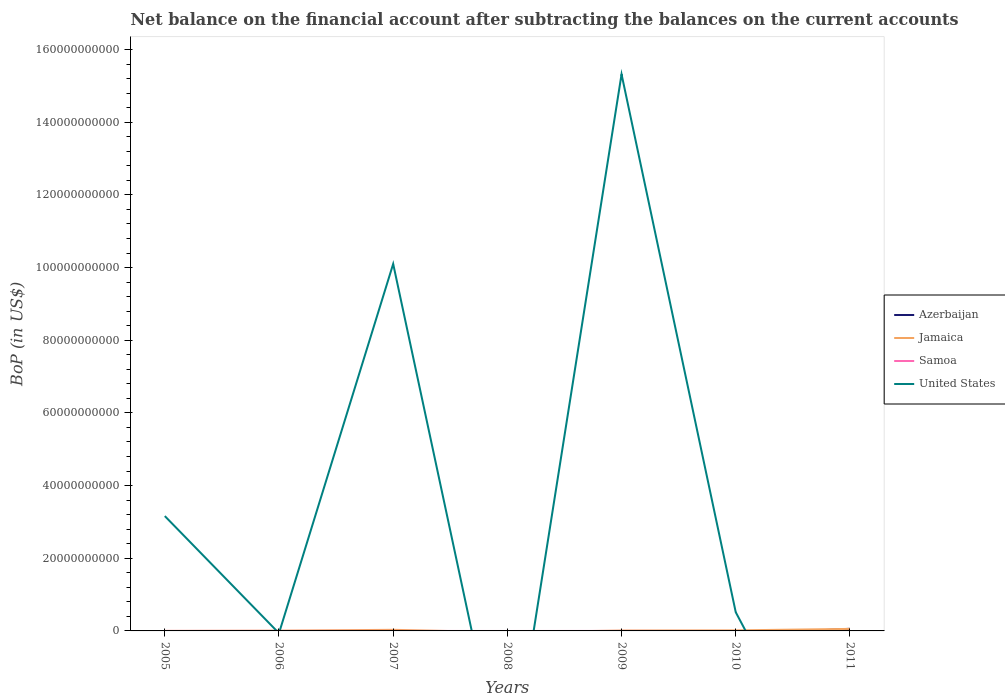How many different coloured lines are there?
Your answer should be compact. 4. Is the number of lines equal to the number of legend labels?
Ensure brevity in your answer.  No. What is the total Balance of Payments in Jamaica in the graph?
Your response must be concise. -7.87e+07. What is the difference between the highest and the second highest Balance of Payments in United States?
Your answer should be very brief. 1.53e+11. What is the difference between the highest and the lowest Balance of Payments in Azerbaijan?
Your response must be concise. 1. Is the Balance of Payments in Azerbaijan strictly greater than the Balance of Payments in Samoa over the years?
Ensure brevity in your answer.  No. How many lines are there?
Your response must be concise. 4. How many years are there in the graph?
Give a very brief answer. 7. Are the values on the major ticks of Y-axis written in scientific E-notation?
Offer a very short reply. No. Does the graph contain grids?
Make the answer very short. No. What is the title of the graph?
Make the answer very short. Net balance on the financial account after subtracting the balances on the current accounts. Does "Maldives" appear as one of the legend labels in the graph?
Give a very brief answer. No. What is the label or title of the Y-axis?
Give a very brief answer. BoP (in US$). What is the BoP (in US$) in Samoa in 2005?
Offer a terse response. 0. What is the BoP (in US$) in United States in 2005?
Ensure brevity in your answer.  3.16e+1. What is the BoP (in US$) of Jamaica in 2006?
Offer a terse response. 7.07e+07. What is the BoP (in US$) of Samoa in 2006?
Ensure brevity in your answer.  6.12e+06. What is the BoP (in US$) in United States in 2006?
Your response must be concise. 0. What is the BoP (in US$) of Azerbaijan in 2007?
Give a very brief answer. 0. What is the BoP (in US$) of Jamaica in 2007?
Keep it short and to the point. 3.03e+08. What is the BoP (in US$) in Samoa in 2007?
Make the answer very short. 0. What is the BoP (in US$) in United States in 2007?
Give a very brief answer. 1.01e+11. What is the BoP (in US$) in Azerbaijan in 2008?
Your response must be concise. 0. What is the BoP (in US$) of Jamaica in 2008?
Your response must be concise. 0. What is the BoP (in US$) in Samoa in 2008?
Keep it short and to the point. 0. What is the BoP (in US$) in Jamaica in 2009?
Make the answer very short. 1.03e+08. What is the BoP (in US$) of Samoa in 2009?
Your answer should be very brief. 2.61e+05. What is the BoP (in US$) of United States in 2009?
Make the answer very short. 1.53e+11. What is the BoP (in US$) of Azerbaijan in 2010?
Your answer should be very brief. 0. What is the BoP (in US$) of Jamaica in 2010?
Keep it short and to the point. 1.49e+08. What is the BoP (in US$) of United States in 2010?
Your answer should be compact. 5.15e+09. What is the BoP (in US$) of Azerbaijan in 2011?
Your answer should be compact. 5.87e+08. What is the BoP (in US$) of Jamaica in 2011?
Your answer should be very brief. 5.57e+08. What is the BoP (in US$) of United States in 2011?
Your answer should be compact. 0. Across all years, what is the maximum BoP (in US$) in Azerbaijan?
Make the answer very short. 5.87e+08. Across all years, what is the maximum BoP (in US$) of Jamaica?
Keep it short and to the point. 5.57e+08. Across all years, what is the maximum BoP (in US$) of Samoa?
Offer a terse response. 6.12e+06. Across all years, what is the maximum BoP (in US$) in United States?
Keep it short and to the point. 1.53e+11. Across all years, what is the minimum BoP (in US$) in Jamaica?
Your response must be concise. 0. What is the total BoP (in US$) of Azerbaijan in the graph?
Provide a succinct answer. 5.87e+08. What is the total BoP (in US$) in Jamaica in the graph?
Your answer should be compact. 1.18e+09. What is the total BoP (in US$) of Samoa in the graph?
Provide a short and direct response. 6.38e+06. What is the total BoP (in US$) in United States in the graph?
Provide a succinct answer. 2.91e+11. What is the difference between the BoP (in US$) of United States in 2005 and that in 2007?
Your answer should be compact. -6.94e+1. What is the difference between the BoP (in US$) in United States in 2005 and that in 2009?
Make the answer very short. -1.22e+11. What is the difference between the BoP (in US$) of United States in 2005 and that in 2010?
Ensure brevity in your answer.  2.65e+1. What is the difference between the BoP (in US$) in Jamaica in 2006 and that in 2007?
Provide a short and direct response. -2.33e+08. What is the difference between the BoP (in US$) in Jamaica in 2006 and that in 2009?
Provide a succinct answer. -3.23e+07. What is the difference between the BoP (in US$) of Samoa in 2006 and that in 2009?
Ensure brevity in your answer.  5.86e+06. What is the difference between the BoP (in US$) in Jamaica in 2006 and that in 2010?
Provide a succinct answer. -7.87e+07. What is the difference between the BoP (in US$) in Jamaica in 2006 and that in 2011?
Offer a terse response. -4.87e+08. What is the difference between the BoP (in US$) in Jamaica in 2007 and that in 2009?
Make the answer very short. 2.00e+08. What is the difference between the BoP (in US$) of United States in 2007 and that in 2009?
Provide a succinct answer. -5.22e+1. What is the difference between the BoP (in US$) in Jamaica in 2007 and that in 2010?
Offer a terse response. 1.54e+08. What is the difference between the BoP (in US$) of United States in 2007 and that in 2010?
Provide a succinct answer. 9.59e+1. What is the difference between the BoP (in US$) in Jamaica in 2007 and that in 2011?
Make the answer very short. -2.54e+08. What is the difference between the BoP (in US$) in Jamaica in 2009 and that in 2010?
Provide a short and direct response. -4.64e+07. What is the difference between the BoP (in US$) of United States in 2009 and that in 2010?
Give a very brief answer. 1.48e+11. What is the difference between the BoP (in US$) in Jamaica in 2009 and that in 2011?
Provide a succinct answer. -4.54e+08. What is the difference between the BoP (in US$) in Jamaica in 2010 and that in 2011?
Your answer should be very brief. -4.08e+08. What is the difference between the BoP (in US$) of Jamaica in 2006 and the BoP (in US$) of United States in 2007?
Offer a terse response. -1.01e+11. What is the difference between the BoP (in US$) in Samoa in 2006 and the BoP (in US$) in United States in 2007?
Your answer should be very brief. -1.01e+11. What is the difference between the BoP (in US$) of Jamaica in 2006 and the BoP (in US$) of Samoa in 2009?
Provide a short and direct response. 7.05e+07. What is the difference between the BoP (in US$) in Jamaica in 2006 and the BoP (in US$) in United States in 2009?
Keep it short and to the point. -1.53e+11. What is the difference between the BoP (in US$) of Samoa in 2006 and the BoP (in US$) of United States in 2009?
Provide a short and direct response. -1.53e+11. What is the difference between the BoP (in US$) of Jamaica in 2006 and the BoP (in US$) of United States in 2010?
Keep it short and to the point. -5.08e+09. What is the difference between the BoP (in US$) in Samoa in 2006 and the BoP (in US$) in United States in 2010?
Provide a succinct answer. -5.14e+09. What is the difference between the BoP (in US$) in Jamaica in 2007 and the BoP (in US$) in Samoa in 2009?
Make the answer very short. 3.03e+08. What is the difference between the BoP (in US$) in Jamaica in 2007 and the BoP (in US$) in United States in 2009?
Keep it short and to the point. -1.53e+11. What is the difference between the BoP (in US$) of Jamaica in 2007 and the BoP (in US$) of United States in 2010?
Your answer should be very brief. -4.84e+09. What is the difference between the BoP (in US$) of Jamaica in 2009 and the BoP (in US$) of United States in 2010?
Provide a short and direct response. -5.04e+09. What is the difference between the BoP (in US$) of Samoa in 2009 and the BoP (in US$) of United States in 2010?
Give a very brief answer. -5.15e+09. What is the average BoP (in US$) of Azerbaijan per year?
Your answer should be very brief. 8.38e+07. What is the average BoP (in US$) of Jamaica per year?
Provide a short and direct response. 1.69e+08. What is the average BoP (in US$) of Samoa per year?
Your response must be concise. 9.11e+05. What is the average BoP (in US$) of United States per year?
Provide a short and direct response. 4.16e+1. In the year 2006, what is the difference between the BoP (in US$) in Jamaica and BoP (in US$) in Samoa?
Keep it short and to the point. 6.46e+07. In the year 2007, what is the difference between the BoP (in US$) of Jamaica and BoP (in US$) of United States?
Your answer should be very brief. -1.01e+11. In the year 2009, what is the difference between the BoP (in US$) of Jamaica and BoP (in US$) of Samoa?
Provide a succinct answer. 1.03e+08. In the year 2009, what is the difference between the BoP (in US$) of Jamaica and BoP (in US$) of United States?
Offer a very short reply. -1.53e+11. In the year 2009, what is the difference between the BoP (in US$) of Samoa and BoP (in US$) of United States?
Ensure brevity in your answer.  -1.53e+11. In the year 2010, what is the difference between the BoP (in US$) in Jamaica and BoP (in US$) in United States?
Your answer should be compact. -5.00e+09. In the year 2011, what is the difference between the BoP (in US$) of Azerbaijan and BoP (in US$) of Jamaica?
Keep it short and to the point. 2.92e+07. What is the ratio of the BoP (in US$) of United States in 2005 to that in 2007?
Offer a terse response. 0.31. What is the ratio of the BoP (in US$) of United States in 2005 to that in 2009?
Your response must be concise. 0.21. What is the ratio of the BoP (in US$) of United States in 2005 to that in 2010?
Make the answer very short. 6.14. What is the ratio of the BoP (in US$) in Jamaica in 2006 to that in 2007?
Provide a succinct answer. 0.23. What is the ratio of the BoP (in US$) of Jamaica in 2006 to that in 2009?
Your answer should be compact. 0.69. What is the ratio of the BoP (in US$) in Samoa in 2006 to that in 2009?
Your response must be concise. 23.43. What is the ratio of the BoP (in US$) in Jamaica in 2006 to that in 2010?
Your response must be concise. 0.47. What is the ratio of the BoP (in US$) of Jamaica in 2006 to that in 2011?
Provide a succinct answer. 0.13. What is the ratio of the BoP (in US$) in Jamaica in 2007 to that in 2009?
Offer a terse response. 2.94. What is the ratio of the BoP (in US$) of United States in 2007 to that in 2009?
Offer a very short reply. 0.66. What is the ratio of the BoP (in US$) of Jamaica in 2007 to that in 2010?
Ensure brevity in your answer.  2.03. What is the ratio of the BoP (in US$) in United States in 2007 to that in 2010?
Ensure brevity in your answer.  19.62. What is the ratio of the BoP (in US$) in Jamaica in 2007 to that in 2011?
Provide a short and direct response. 0.54. What is the ratio of the BoP (in US$) of Jamaica in 2009 to that in 2010?
Make the answer very short. 0.69. What is the ratio of the BoP (in US$) of United States in 2009 to that in 2010?
Keep it short and to the point. 29.76. What is the ratio of the BoP (in US$) of Jamaica in 2009 to that in 2011?
Provide a short and direct response. 0.18. What is the ratio of the BoP (in US$) in Jamaica in 2010 to that in 2011?
Keep it short and to the point. 0.27. What is the difference between the highest and the second highest BoP (in US$) of Jamaica?
Your response must be concise. 2.54e+08. What is the difference between the highest and the second highest BoP (in US$) in United States?
Offer a terse response. 5.22e+1. What is the difference between the highest and the lowest BoP (in US$) in Azerbaijan?
Offer a very short reply. 5.87e+08. What is the difference between the highest and the lowest BoP (in US$) of Jamaica?
Provide a succinct answer. 5.57e+08. What is the difference between the highest and the lowest BoP (in US$) in Samoa?
Your answer should be very brief. 6.12e+06. What is the difference between the highest and the lowest BoP (in US$) of United States?
Your answer should be compact. 1.53e+11. 